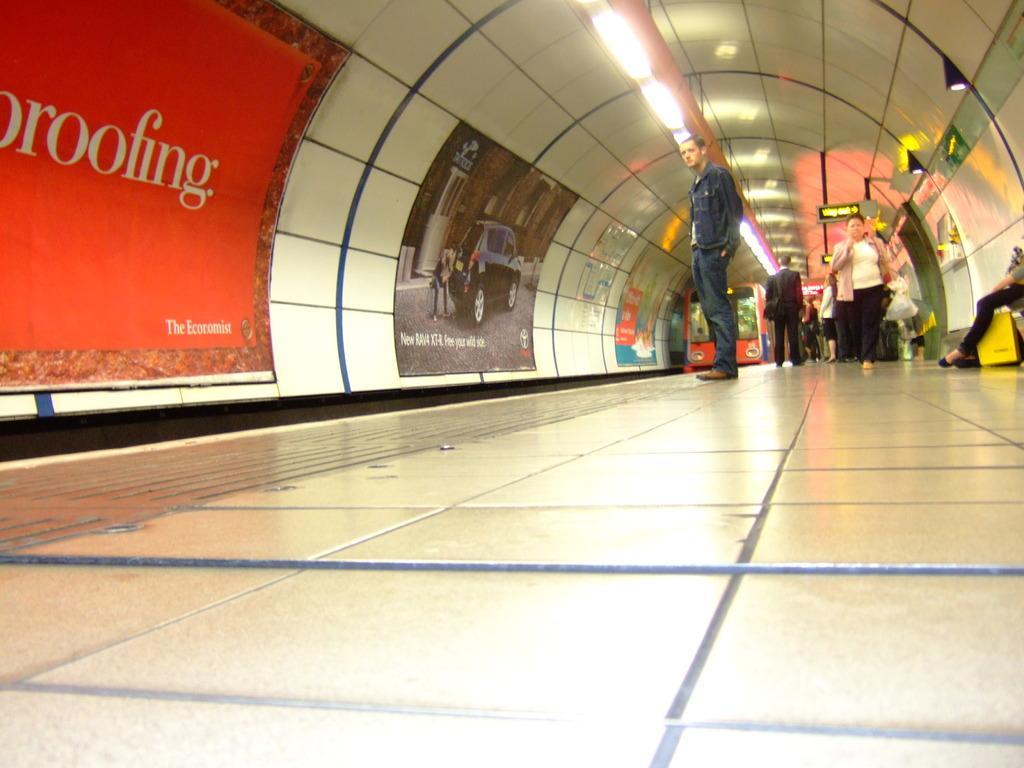In one or two sentences, can you explain what this image depicts? In this image we can see the people on the floor. We can also see the train and also the posters attached to the wall. Image also consists of the ceiling lights. 